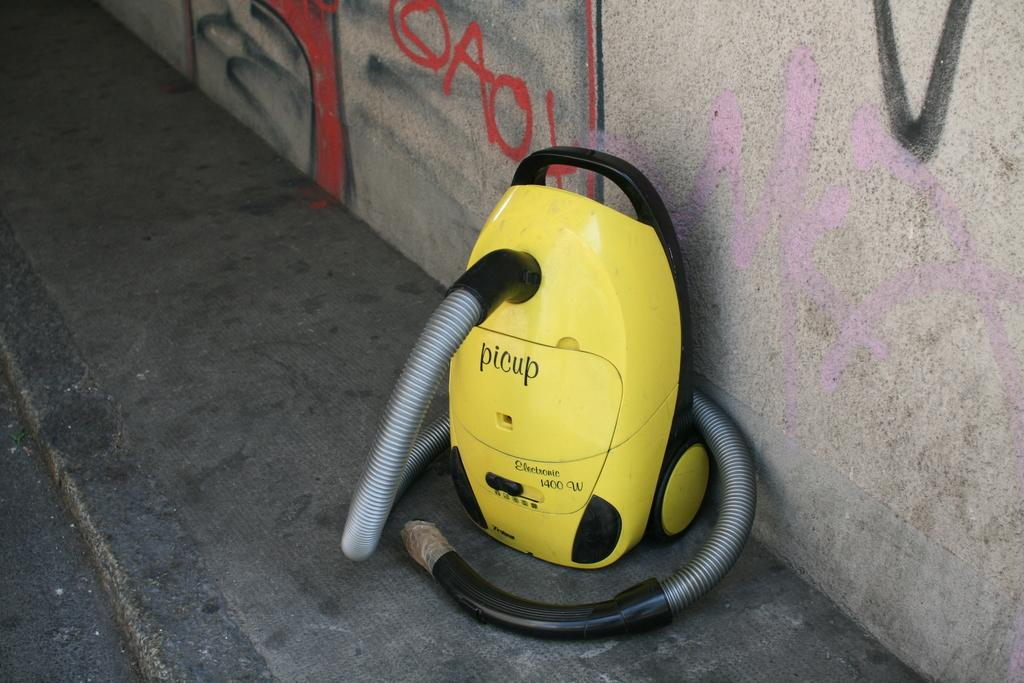What is the main subject in the center of the image? There is a machine in the center of the image. Where is the machine located? The machine is on the floor. What can be seen on the wall in the background of the image? There is graffiti on the wall in the background of the image. What type of paper is being used to make a match in the image? There is no paper or match present in the image. What is being served for breakfast in the image? There is no reference to breakfast or any food items in the image. 